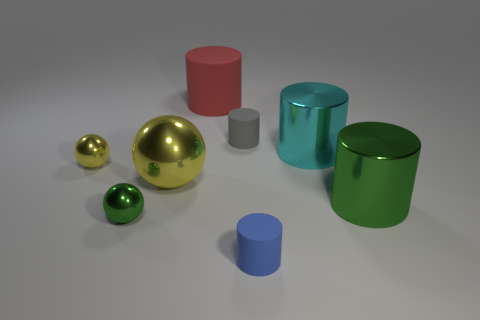Subtract all green balls. How many balls are left? 2 Subtract all green balls. How many balls are left? 2 Add 1 small purple shiny cubes. How many objects exist? 9 Subtract 1 balls. How many balls are left? 2 Subtract all cylinders. How many objects are left? 3 Subtract all red cylinders. How many yellow balls are left? 2 Subtract 1 green balls. How many objects are left? 7 Subtract all green spheres. Subtract all blue blocks. How many spheres are left? 2 Subtract all tiny green balls. Subtract all big rubber objects. How many objects are left? 6 Add 1 big yellow metallic objects. How many big yellow metallic objects are left? 2 